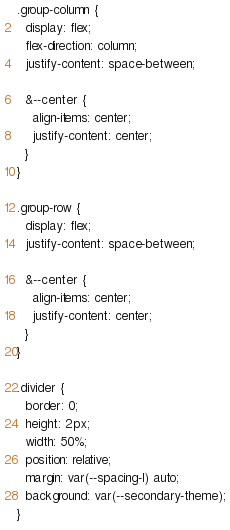<code> <loc_0><loc_0><loc_500><loc_500><_CSS_>.group-column {
  display: flex;
  flex-direction: column;
  justify-content: space-between;

  &--center {
    align-items: center;
    justify-content: center;
  }
}

.group-row {
  display: flex;
  justify-content: space-between;

  &--center {
    align-items: center;
    justify-content: center;
  }
}

.divider {
  border: 0;
  height: 2px;
  width: 50%;
  position: relative;
  margin: var(--spacing-l) auto;
  background: var(--secondary-theme);
}
</code> 